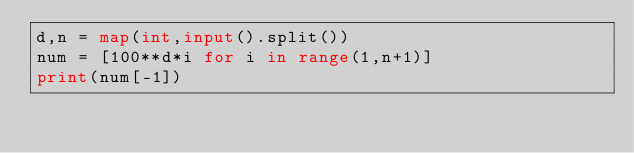<code> <loc_0><loc_0><loc_500><loc_500><_Python_>d,n = map(int,input().split())
num = [100**d*i for i in range(1,n+1)]
print(num[-1])</code> 